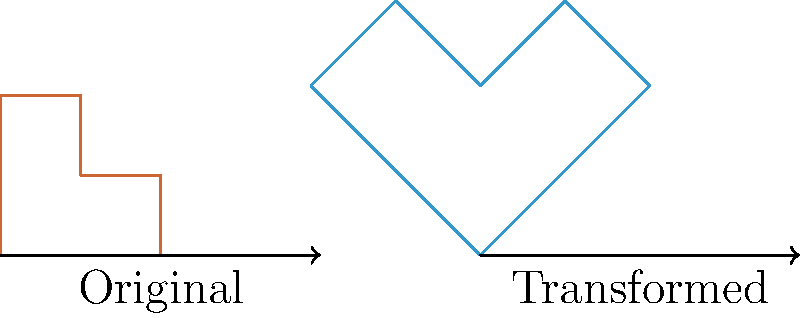As part of your business rebranding, you need to transform your logo. The new design requires scaling the original logo by a factor of 1.5 and rotating it 45 degrees clockwise. If the original logo is represented by the vector $\mathbf{v} = \begin{pmatrix} 2 \\ 1 \end{pmatrix}$, what is the resulting vector $\mathbf{v}'$ after the transformation? To solve this problem, we'll follow these steps:

1. Scale the vector:
   Scaling by a factor of 1.5 means multiplying each component by 1.5.
   $\mathbf{v}_{\text{scaled}} = 1.5 \times \begin{pmatrix} 2 \\ 1 \end{pmatrix} = \begin{pmatrix} 3 \\ 1.5 \end{pmatrix}$

2. Rotate the scaled vector:
   To rotate a vector by 45° clockwise, we use the rotation matrix:
   $R_{-45°} = \begin{pmatrix} \cos(-45°) & -\sin(-45°) \\ \sin(-45°) & \cos(-45°) \end{pmatrix} = \begin{pmatrix} \frac{\sqrt{2}}{2} & \frac{\sqrt{2}}{2} \\ -\frac{\sqrt{2}}{2} & \frac{\sqrt{2}}{2} \end{pmatrix}$

3. Apply the rotation:
   $\mathbf{v}' = R_{-45°} \times \mathbf{v}_{\text{scaled}}$

   $\mathbf{v}' = \begin{pmatrix} \frac{\sqrt{2}}{2} & \frac{\sqrt{2}}{2} \\ -\frac{\sqrt{2}}{2} & \frac{\sqrt{2}}{2} \end{pmatrix} \times \begin{pmatrix} 3 \\ 1.5 \end{pmatrix}$

4. Calculate the result:
   $\mathbf{v}' = \begin{pmatrix} \frac{\sqrt{2}}{2} \times 3 + \frac{\sqrt{2}}{2} \times 1.5 \\ -\frac{\sqrt{2}}{2} \times 3 + \frac{\sqrt{2}}{2} \times 1.5 \end{pmatrix}$

   $\mathbf{v}' = \begin{pmatrix} \frac{3\sqrt{2}}{2} + \frac{3\sqrt{2}}{4} \\ -\frac{3\sqrt{2}}{2} + \frac{3\sqrt{2}}{4} \end{pmatrix}$

   $\mathbf{v}' = \begin{pmatrix} \frac{9\sqrt{2}}{4} \\ -\frac{3\sqrt{2}}{4} \end{pmatrix}$
Answer: $\mathbf{v}' = \begin{pmatrix} \frac{9\sqrt{2}}{4} \\ -\frac{3\sqrt{2}}{4} \end{pmatrix}$ 